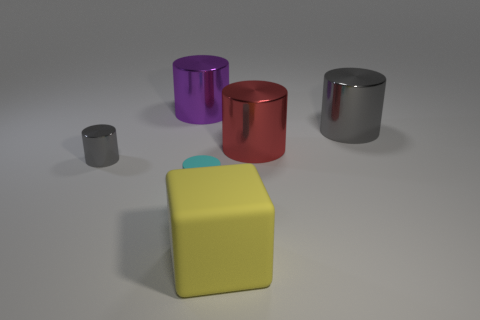There is a big yellow thing in front of the gray metal object that is right of the big yellow block in front of the small gray object; what shape is it? cube 